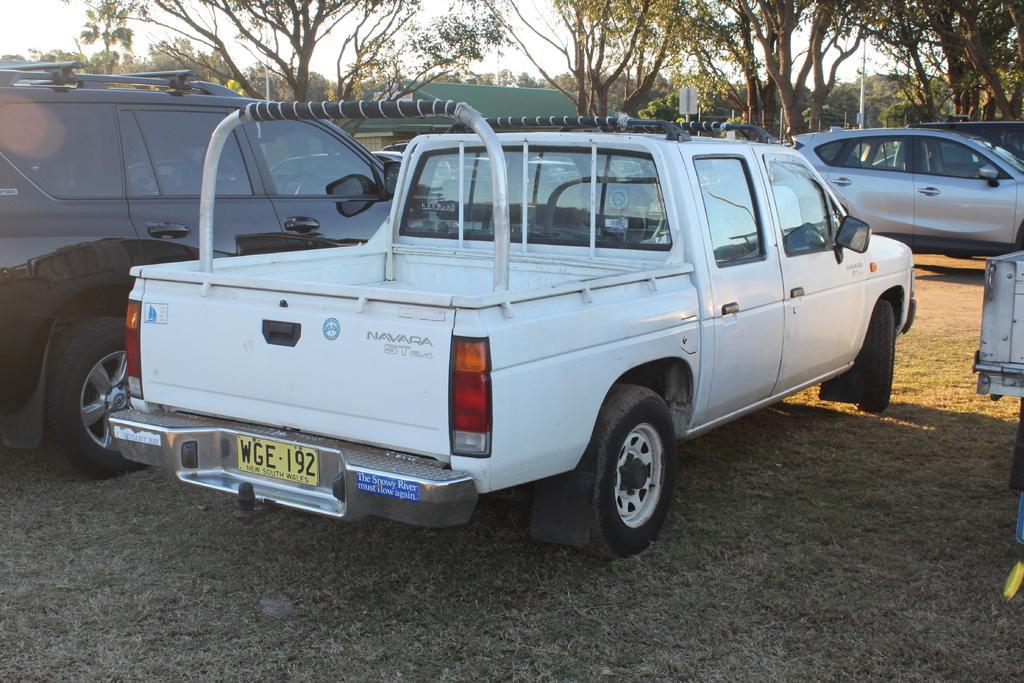How would you summarize this image in a sentence or two? In the image there are different vehicles parked on the ground and in the background there are trees. 